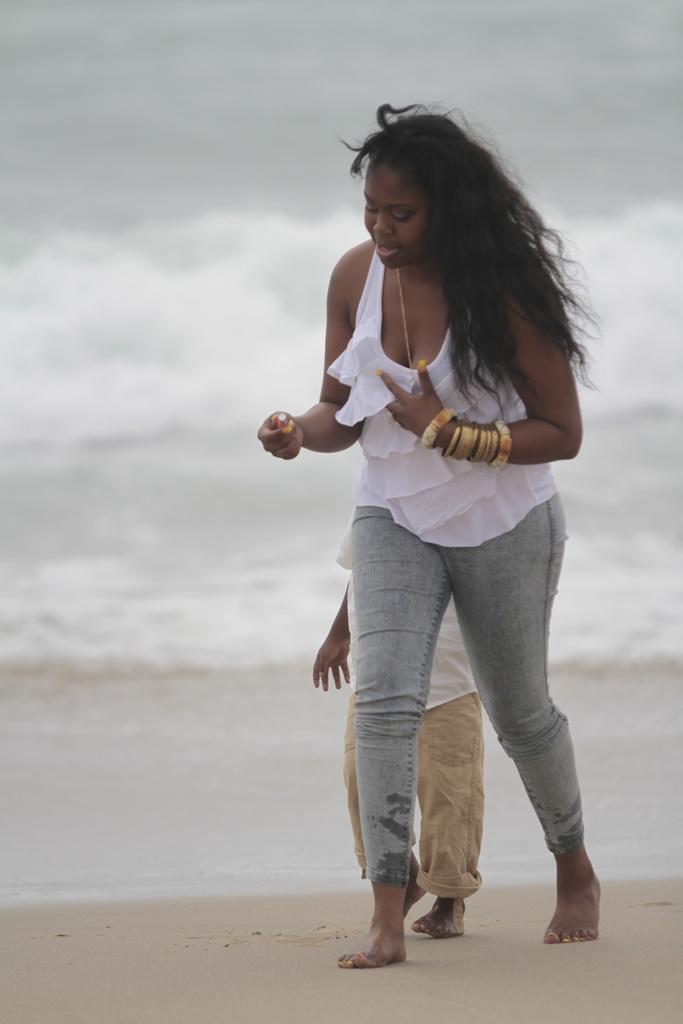How would you summarize this image in a sentence or two? In this image there is a woman walking on the land. Behind her there is a kid walking. Background there is water having tides. 